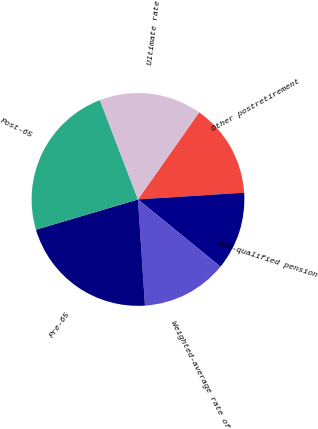Convert chart. <chart><loc_0><loc_0><loc_500><loc_500><pie_chart><fcel>Other postretirement<fcel>Non-qualified pension<fcel>Weighted-average rate of<fcel>Pre-65<fcel>Post-65<fcel>Ultimate rate<nl><fcel>14.25%<fcel>11.89%<fcel>13.07%<fcel>21.46%<fcel>23.75%<fcel>15.56%<nl></chart> 